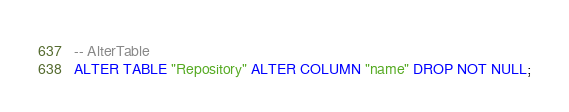<code> <loc_0><loc_0><loc_500><loc_500><_SQL_>-- AlterTable
ALTER TABLE "Repository" ALTER COLUMN "name" DROP NOT NULL;
</code> 